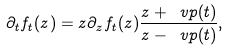Convert formula to latex. <formula><loc_0><loc_0><loc_500><loc_500>\partial _ { t } f _ { t } ( z ) = z \partial _ { z } f _ { t } ( z ) \frac { z + \ v p ( t ) } { z - \ v p ( t ) } ,</formula> 